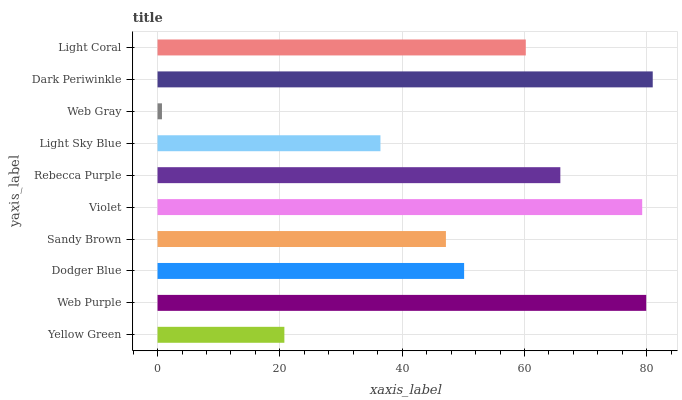Is Web Gray the minimum?
Answer yes or no. Yes. Is Dark Periwinkle the maximum?
Answer yes or no. Yes. Is Web Purple the minimum?
Answer yes or no. No. Is Web Purple the maximum?
Answer yes or no. No. Is Web Purple greater than Yellow Green?
Answer yes or no. Yes. Is Yellow Green less than Web Purple?
Answer yes or no. Yes. Is Yellow Green greater than Web Purple?
Answer yes or no. No. Is Web Purple less than Yellow Green?
Answer yes or no. No. Is Light Coral the high median?
Answer yes or no. Yes. Is Dodger Blue the low median?
Answer yes or no. Yes. Is Light Sky Blue the high median?
Answer yes or no. No. Is Sandy Brown the low median?
Answer yes or no. No. 